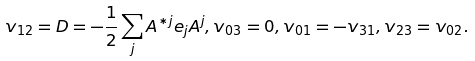<formula> <loc_0><loc_0><loc_500><loc_500>v _ { 1 2 } = D = - \frac { 1 } { 2 } \sum _ { j } A ^ { * j } e _ { j } A ^ { j } , v _ { 0 3 } = 0 , v _ { 0 1 } = - v _ { 3 1 } , v _ { 2 3 } = v _ { 0 2 } .</formula> 